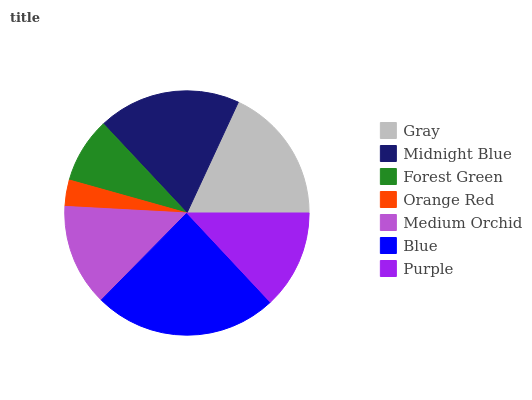Is Orange Red the minimum?
Answer yes or no. Yes. Is Blue the maximum?
Answer yes or no. Yes. Is Midnight Blue the minimum?
Answer yes or no. No. Is Midnight Blue the maximum?
Answer yes or no. No. Is Midnight Blue greater than Gray?
Answer yes or no. Yes. Is Gray less than Midnight Blue?
Answer yes or no. Yes. Is Gray greater than Midnight Blue?
Answer yes or no. No. Is Midnight Blue less than Gray?
Answer yes or no. No. Is Medium Orchid the high median?
Answer yes or no. Yes. Is Medium Orchid the low median?
Answer yes or no. Yes. Is Orange Red the high median?
Answer yes or no. No. Is Midnight Blue the low median?
Answer yes or no. No. 